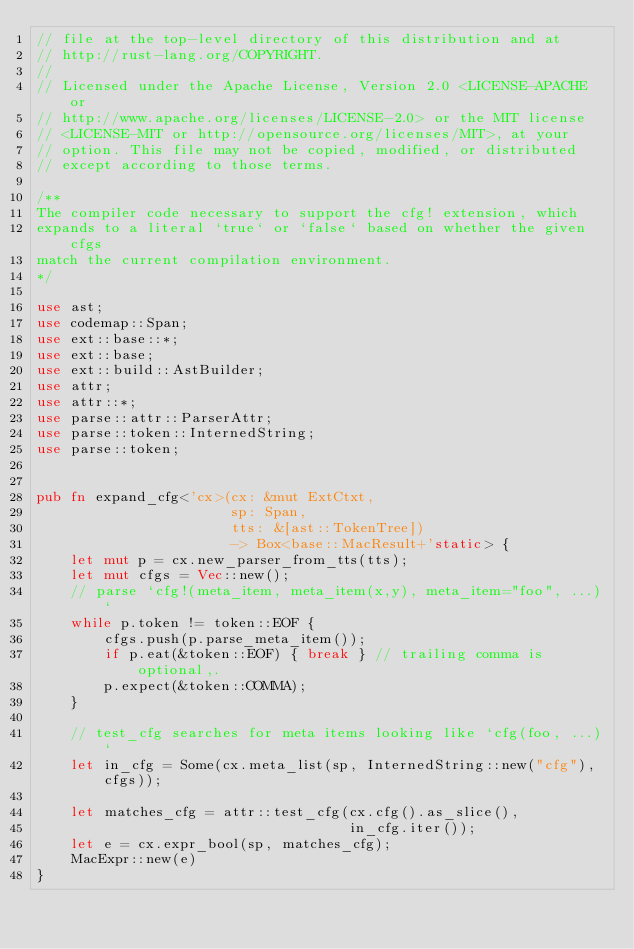Convert code to text. <code><loc_0><loc_0><loc_500><loc_500><_Rust_>// file at the top-level directory of this distribution and at
// http://rust-lang.org/COPYRIGHT.
//
// Licensed under the Apache License, Version 2.0 <LICENSE-APACHE or
// http://www.apache.org/licenses/LICENSE-2.0> or the MIT license
// <LICENSE-MIT or http://opensource.org/licenses/MIT>, at your
// option. This file may not be copied, modified, or distributed
// except according to those terms.

/**
The compiler code necessary to support the cfg! extension, which
expands to a literal `true` or `false` based on whether the given cfgs
match the current compilation environment.
*/

use ast;
use codemap::Span;
use ext::base::*;
use ext::base;
use ext::build::AstBuilder;
use attr;
use attr::*;
use parse::attr::ParserAttr;
use parse::token::InternedString;
use parse::token;


pub fn expand_cfg<'cx>(cx: &mut ExtCtxt,
                       sp: Span,
                       tts: &[ast::TokenTree])
                       -> Box<base::MacResult+'static> {
    let mut p = cx.new_parser_from_tts(tts);
    let mut cfgs = Vec::new();
    // parse `cfg!(meta_item, meta_item(x,y), meta_item="foo", ...)`
    while p.token != token::EOF {
        cfgs.push(p.parse_meta_item());
        if p.eat(&token::EOF) { break } // trailing comma is optional,.
        p.expect(&token::COMMA);
    }

    // test_cfg searches for meta items looking like `cfg(foo, ...)`
    let in_cfg = Some(cx.meta_list(sp, InternedString::new("cfg"), cfgs));

    let matches_cfg = attr::test_cfg(cx.cfg().as_slice(),
                                     in_cfg.iter());
    let e = cx.expr_bool(sp, matches_cfg);
    MacExpr::new(e)
}
</code> 